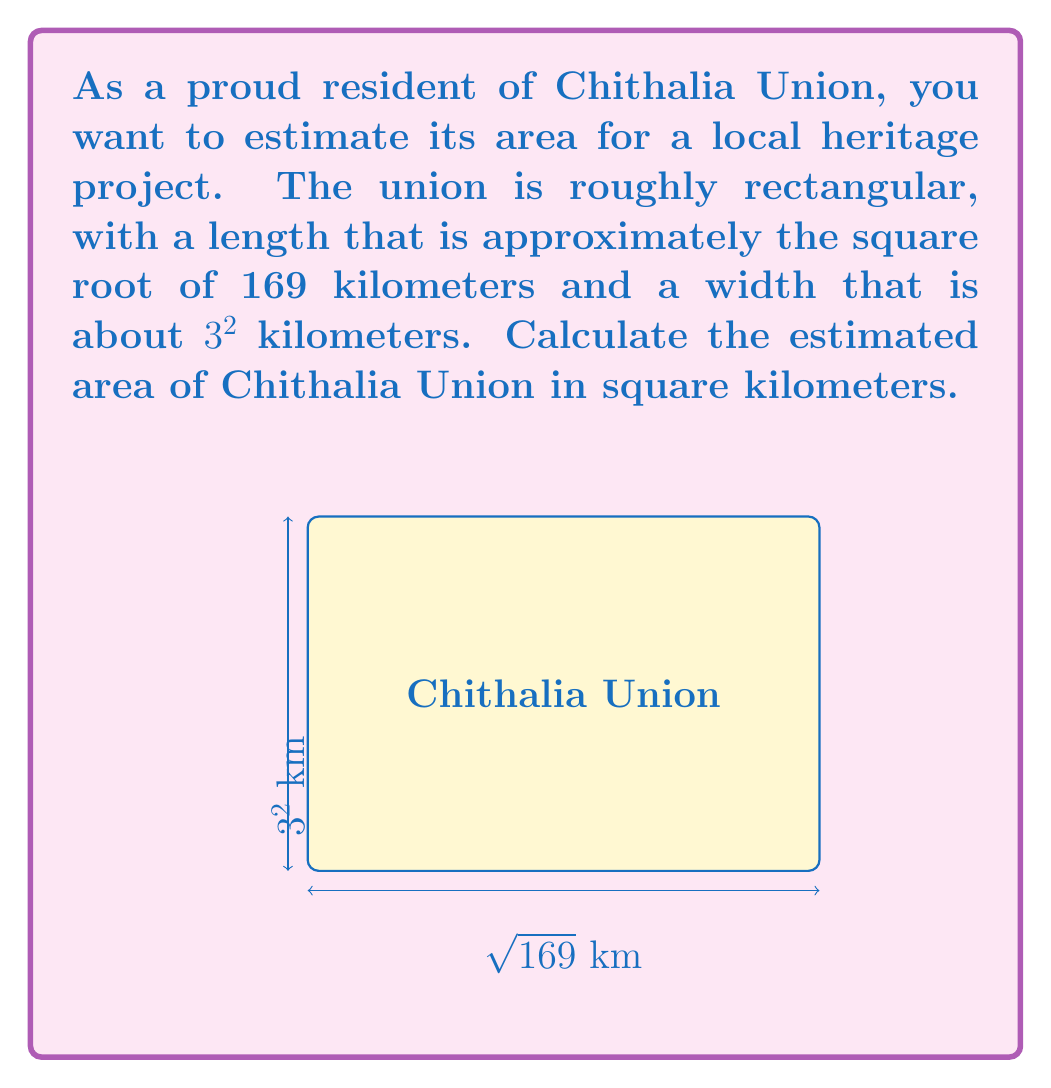What is the answer to this math problem? Let's approach this step-by-step:

1) First, let's calculate the length of Chithalia Union:
   $\text{Length} = \sqrt{169}$ km
   $\sqrt{169} = 13$ km

2) Now, let's calculate the width:
   $\text{Width} = 3^2$ km
   $3^2 = 3 \times 3 = 9$ km

3) To find the area of a rectangle, we multiply its length by its width:
   $\text{Area} = \text{Length} \times \text{Width}$

4) Substituting our values:
   $\text{Area} = 13 \text{ km} \times 9 \text{ km}$

5) Calculating:
   $\text{Area} = 117 \text{ km}^2$

Therefore, the estimated area of Chithalia Union is 117 square kilometers.
Answer: $117 \text{ km}^2$ 